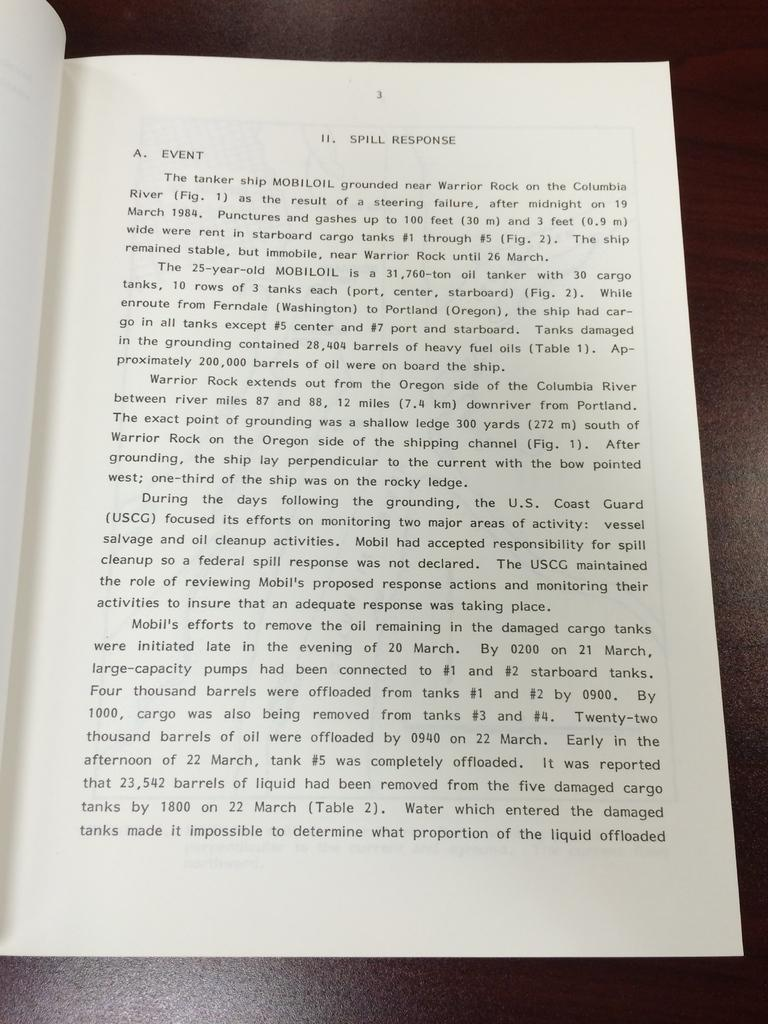Provide a one-sentence caption for the provided image. A book is open to page three with the top text talking about spill response. 